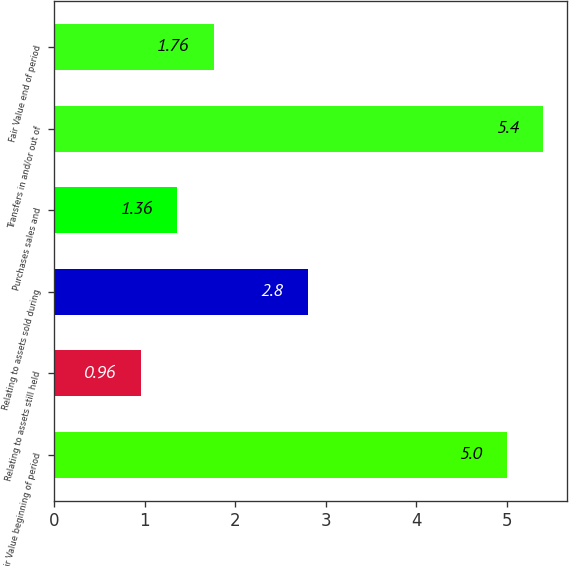Convert chart. <chart><loc_0><loc_0><loc_500><loc_500><bar_chart><fcel>Fair Value beginning of period<fcel>Relating to assets still held<fcel>Relating to assets sold during<fcel>Purchases sales and<fcel>Transfers in and/or out of<fcel>Fair Value end of period<nl><fcel>5<fcel>0.96<fcel>2.8<fcel>1.36<fcel>5.4<fcel>1.76<nl></chart> 